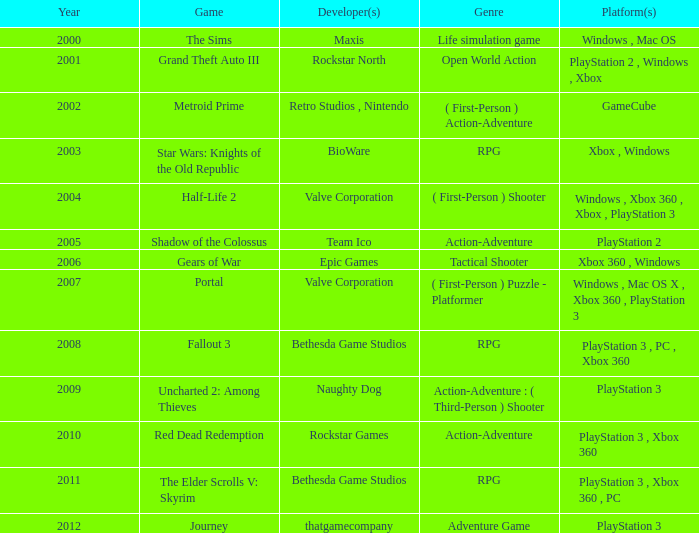What game was in 2011? The Elder Scrolls V: Skyrim. 